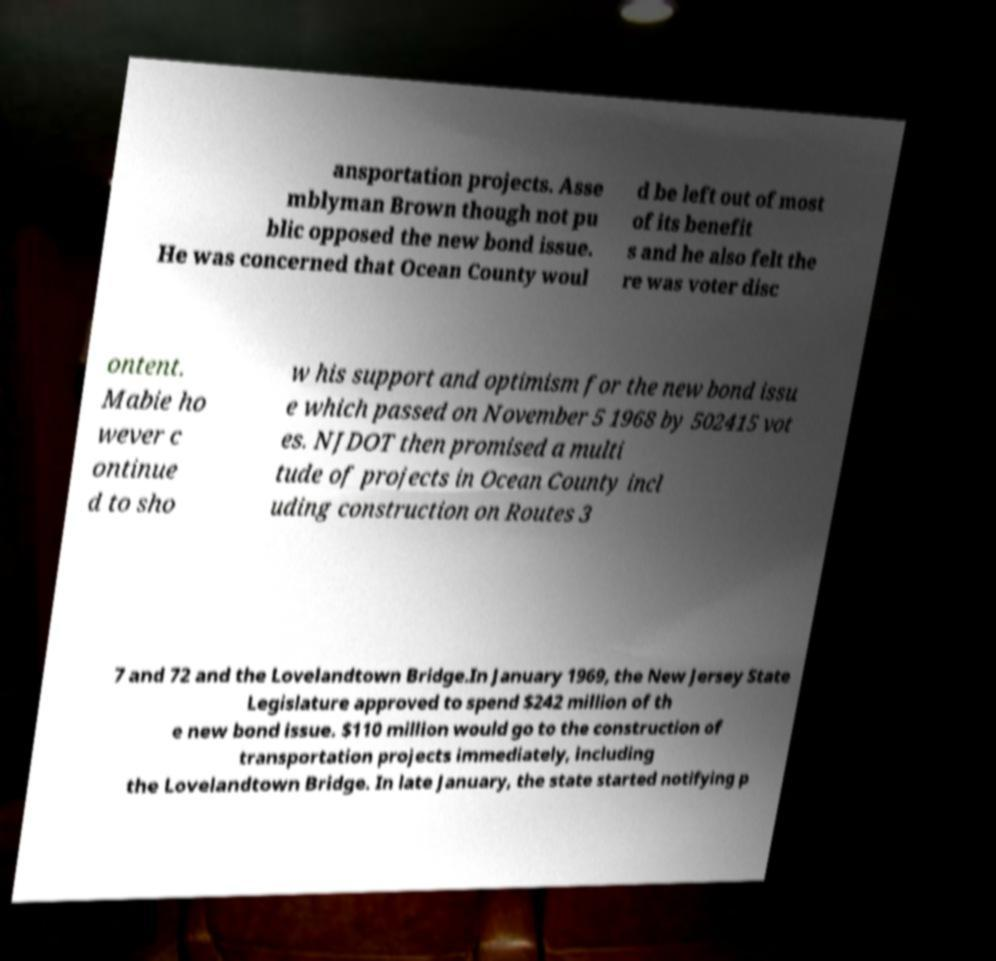Could you assist in decoding the text presented in this image and type it out clearly? ansportation projects. Asse mblyman Brown though not pu blic opposed the new bond issue. He was concerned that Ocean County woul d be left out of most of its benefit s and he also felt the re was voter disc ontent. Mabie ho wever c ontinue d to sho w his support and optimism for the new bond issu e which passed on November 5 1968 by 502415 vot es. NJDOT then promised a multi tude of projects in Ocean County incl uding construction on Routes 3 7 and 72 and the Lovelandtown Bridge.In January 1969, the New Jersey State Legislature approved to spend $242 million of th e new bond issue. $110 million would go to the construction of transportation projects immediately, including the Lovelandtown Bridge. In late January, the state started notifying p 